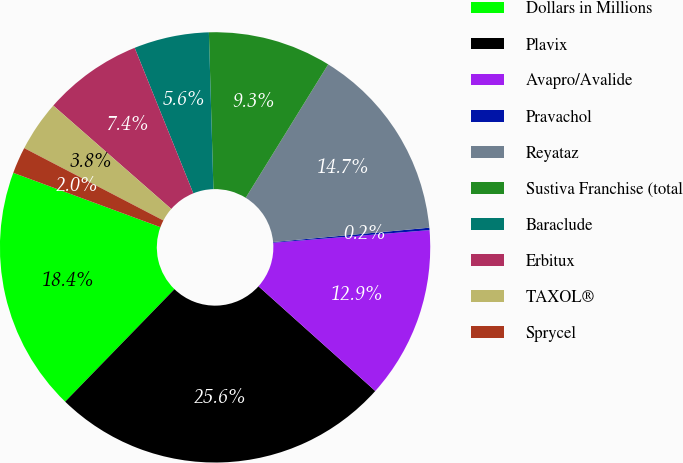Convert chart to OTSL. <chart><loc_0><loc_0><loc_500><loc_500><pie_chart><fcel>Dollars in Millions<fcel>Plavix<fcel>Avapro/Avalide<fcel>Pravachol<fcel>Reyataz<fcel>Sustiva Franchise (total<fcel>Baraclude<fcel>Erbitux<fcel>TAXOL®<fcel>Sprycel<nl><fcel>18.36%<fcel>25.64%<fcel>12.91%<fcel>0.18%<fcel>14.73%<fcel>9.27%<fcel>5.64%<fcel>7.45%<fcel>3.82%<fcel>2.0%<nl></chart> 